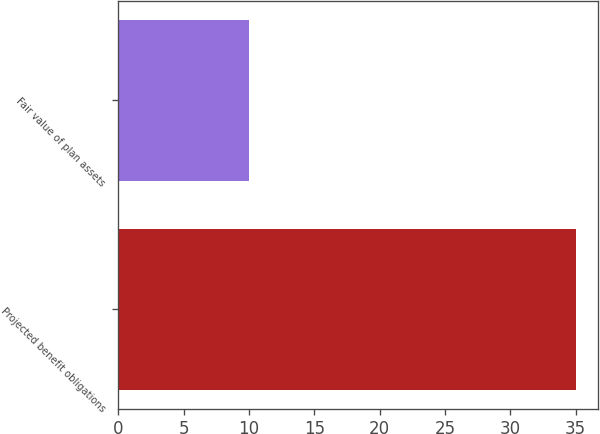<chart> <loc_0><loc_0><loc_500><loc_500><bar_chart><fcel>Projected benefit obligations<fcel>Fair value of plan assets<nl><fcel>35<fcel>10<nl></chart> 